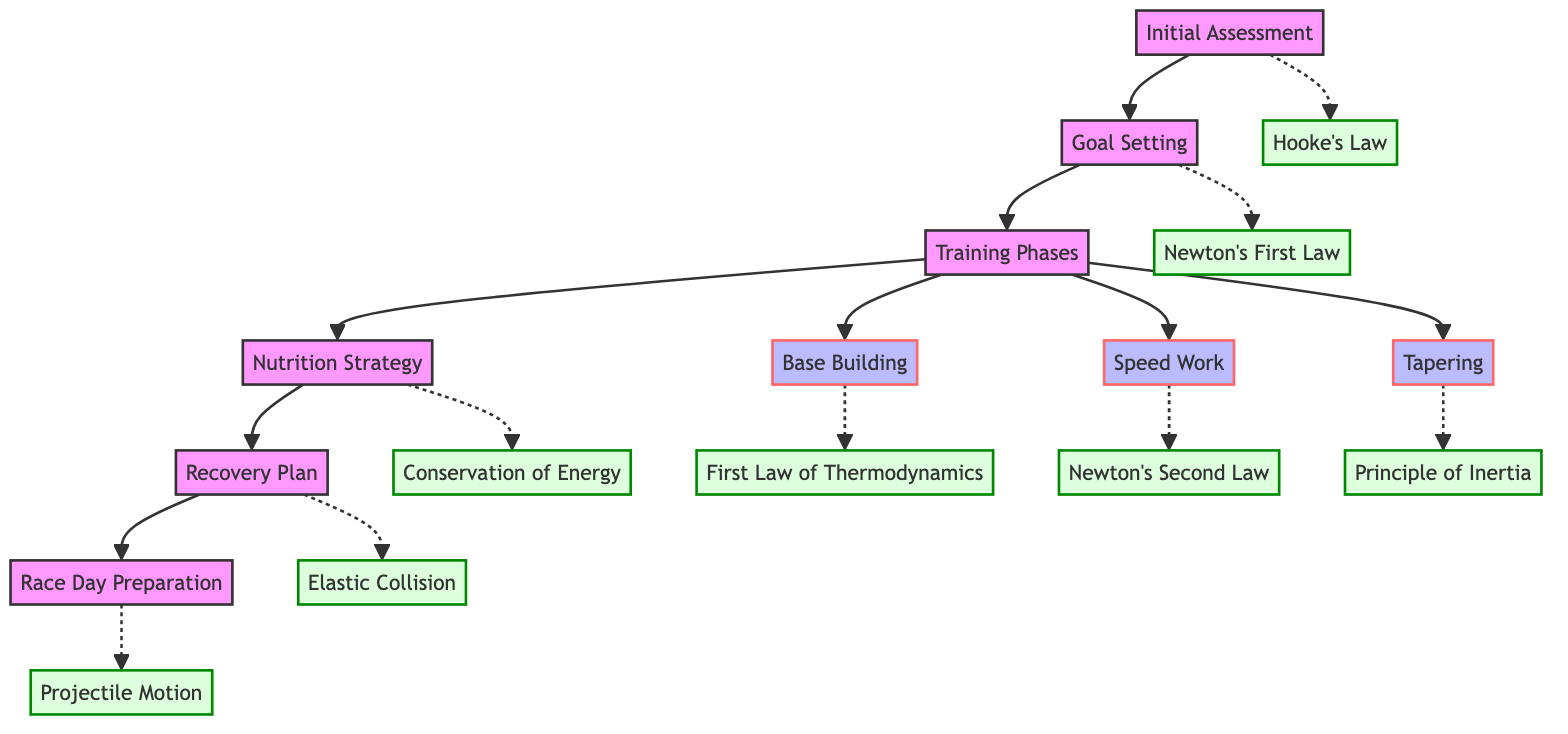What is the first step in the marathon training plan? The flowchart shows that the initial step is "Initial Assessment," which determines the runner's current fitness level and goals.
Answer: Initial Assessment How many phases are included in the "Training Phases"? The diagram outlines three specific phases under "Training Phases": "Base Building," "Speed Work," and "Tapering."
Answer: Three What physical law parallels with "Goal Setting"? According to the diagram, "Goal Setting" is parallel to "Newton's First Law."
Answer: Newton's First Law Which part of the training plan focuses on nutrition? The diagram identifies "Nutrition Strategy" as the section that designs a diet plan supporting intense training and recovery.
Answer: Nutrition Strategy What is the connection between "Base Building" and a physical law? The flowchart links "Base Building" to "First Law of Thermodynamics," showing how energy input increases internal energy.
Answer: First Law of Thermodynamics What is the outcome of "Recovery Plan"? The diagram states that the outcome involves implementing strategies such as rest days, sleep, and active recovery for optimal fitness retention, paralleling it with "Elastic Collision."
Answer: Elastic Collision How does the "Tapering" phase relate to physical laws? The connection in the diagram shows that "Tapering" is aligned with the "Principle of Inertia," emphasizing rest to minimize stress and optimize performance.
Answer: Principle of Inertia What strategy is emphasized for Race Day Preparation? The flowchart indicates that Race Day Preparation details a plan for pacing and hydration to maximize performance efficiency on marathon day.
Answer: Pacing and hydration What is the last node in the flowchart? The last step shown in the diagram is "Race Day Preparation," which comes after the recovery plan.
Answer: Race Day Preparation 